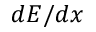Convert formula to latex. <formula><loc_0><loc_0><loc_500><loc_500>d E / d x</formula> 